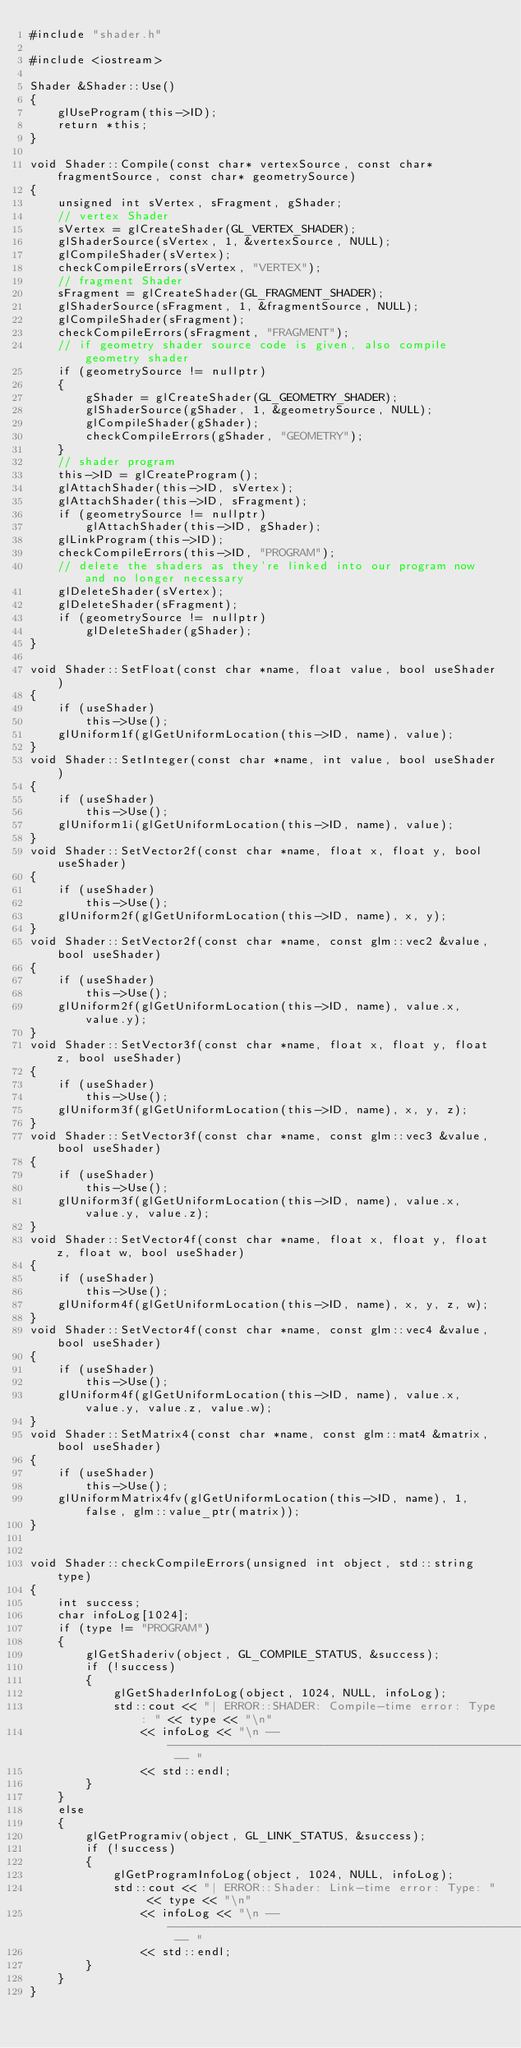Convert code to text. <code><loc_0><loc_0><loc_500><loc_500><_C++_>#include "shader.h"

#include <iostream>

Shader &Shader::Use()
{
    glUseProgram(this->ID);
    return *this;
}

void Shader::Compile(const char* vertexSource, const char* fragmentSource, const char* geometrySource)
{
    unsigned int sVertex, sFragment, gShader;
    // vertex Shader
    sVertex = glCreateShader(GL_VERTEX_SHADER);
    glShaderSource(sVertex, 1, &vertexSource, NULL);
    glCompileShader(sVertex);
    checkCompileErrors(sVertex, "VERTEX");
    // fragment Shader
    sFragment = glCreateShader(GL_FRAGMENT_SHADER);
    glShaderSource(sFragment, 1, &fragmentSource, NULL);
    glCompileShader(sFragment);
    checkCompileErrors(sFragment, "FRAGMENT");
    // if geometry shader source code is given, also compile geometry shader
    if (geometrySource != nullptr)
    {
        gShader = glCreateShader(GL_GEOMETRY_SHADER);
        glShaderSource(gShader, 1, &geometrySource, NULL);
        glCompileShader(gShader);
        checkCompileErrors(gShader, "GEOMETRY");
    }
    // shader program
    this->ID = glCreateProgram();
    glAttachShader(this->ID, sVertex);
    glAttachShader(this->ID, sFragment);
    if (geometrySource != nullptr)
        glAttachShader(this->ID, gShader);
    glLinkProgram(this->ID);
    checkCompileErrors(this->ID, "PROGRAM");
    // delete the shaders as they're linked into our program now and no longer necessary
    glDeleteShader(sVertex);
    glDeleteShader(sFragment);
    if (geometrySource != nullptr)
        glDeleteShader(gShader);
}

void Shader::SetFloat(const char *name, float value, bool useShader)
{
    if (useShader)
        this->Use();
    glUniform1f(glGetUniformLocation(this->ID, name), value);
}
void Shader::SetInteger(const char *name, int value, bool useShader)
{
    if (useShader)
        this->Use();
    glUniform1i(glGetUniformLocation(this->ID, name), value);
}
void Shader::SetVector2f(const char *name, float x, float y, bool useShader)
{
    if (useShader)
        this->Use();
    glUniform2f(glGetUniformLocation(this->ID, name), x, y);
}
void Shader::SetVector2f(const char *name, const glm::vec2 &value, bool useShader)
{
    if (useShader)
        this->Use();
    glUniform2f(glGetUniformLocation(this->ID, name), value.x, value.y);
}
void Shader::SetVector3f(const char *name, float x, float y, float z, bool useShader)
{
    if (useShader)
        this->Use();
    glUniform3f(glGetUniformLocation(this->ID, name), x, y, z);
}
void Shader::SetVector3f(const char *name, const glm::vec3 &value, bool useShader)
{
    if (useShader)
        this->Use();
    glUniform3f(glGetUniformLocation(this->ID, name), value.x, value.y, value.z);
}
void Shader::SetVector4f(const char *name, float x, float y, float z, float w, bool useShader)
{
    if (useShader)
        this->Use();
    glUniform4f(glGetUniformLocation(this->ID, name), x, y, z, w);
}
void Shader::SetVector4f(const char *name, const glm::vec4 &value, bool useShader)
{
    if (useShader)
        this->Use();
    glUniform4f(glGetUniformLocation(this->ID, name), value.x, value.y, value.z, value.w);
}
void Shader::SetMatrix4(const char *name, const glm::mat4 &matrix, bool useShader)
{
    if (useShader)
        this->Use();
    glUniformMatrix4fv(glGetUniformLocation(this->ID, name), 1, false, glm::value_ptr(matrix));
}


void Shader::checkCompileErrors(unsigned int object, std::string type)
{
    int success;
    char infoLog[1024];
    if (type != "PROGRAM")
    {
        glGetShaderiv(object, GL_COMPILE_STATUS, &success);
        if (!success)
        {
            glGetShaderInfoLog(object, 1024, NULL, infoLog);
            std::cout << "| ERROR::SHADER: Compile-time error: Type: " << type << "\n"
                << infoLog << "\n -- --------------------------------------------------- -- "
                << std::endl;
        }
    }
    else
    {
        glGetProgramiv(object, GL_LINK_STATUS, &success);
        if (!success)
        {
            glGetProgramInfoLog(object, 1024, NULL, infoLog);
            std::cout << "| ERROR::Shader: Link-time error: Type: " << type << "\n"
                << infoLog << "\n -- --------------------------------------------------- -- "
                << std::endl;
        }
    }
}</code> 